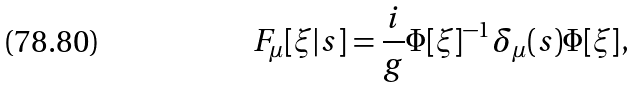Convert formula to latex. <formula><loc_0><loc_0><loc_500><loc_500>F _ { \mu } [ \xi | s ] = \frac { i } { g } \Phi [ \xi ] ^ { - 1 } \delta _ { \mu } ( s ) \Phi [ \xi ] ,</formula> 